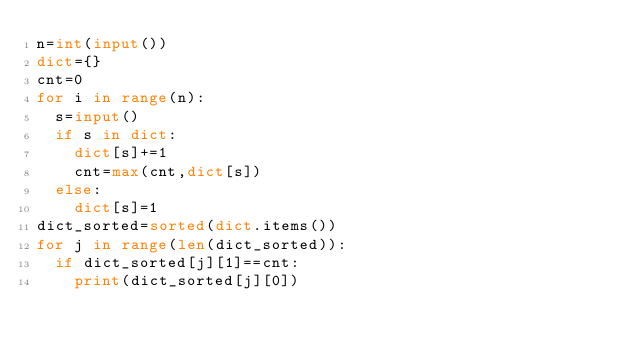Convert code to text. <code><loc_0><loc_0><loc_500><loc_500><_Python_>n=int(input())
dict={}
cnt=0
for i in range(n):
  s=input()
  if s in dict:
    dict[s]+=1
    cnt=max(cnt,dict[s])
  else:
    dict[s]=1
dict_sorted=sorted(dict.items())
for j in range(len(dict_sorted)):
  if dict_sorted[j][1]==cnt:
    print(dict_sorted[j][0])</code> 